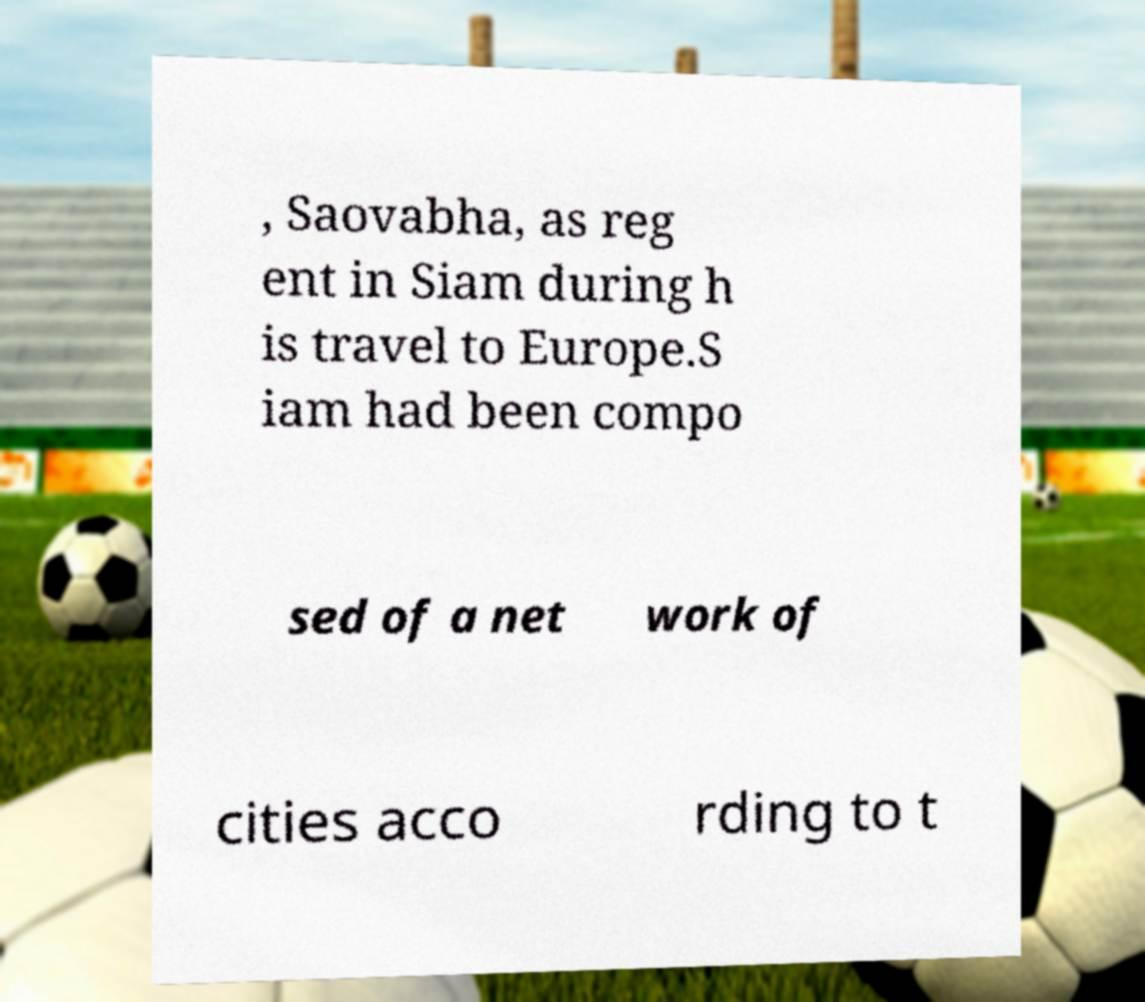There's text embedded in this image that I need extracted. Can you transcribe it verbatim? , Saovabha, as reg ent in Siam during h is travel to Europe.S iam had been compo sed of a net work of cities acco rding to t 